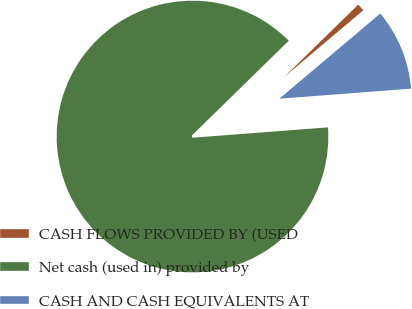Convert chart to OTSL. <chart><loc_0><loc_0><loc_500><loc_500><pie_chart><fcel>CASH FLOWS PROVIDED BY (USED<fcel>Net cash (used in) provided by<fcel>CASH AND CASH EQUIVALENTS AT<nl><fcel>1.17%<fcel>88.88%<fcel>9.94%<nl></chart> 